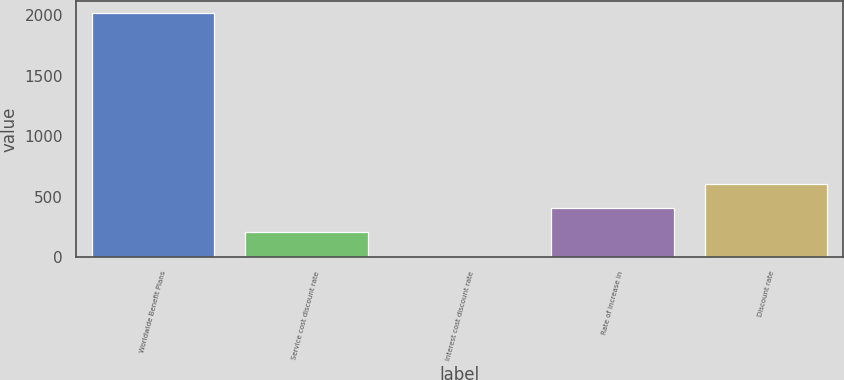<chart> <loc_0><loc_0><loc_500><loc_500><bar_chart><fcel>Worldwide Benefit Plans<fcel>Service cost discount rate<fcel>Interest cost discount rate<fcel>Rate of increase in<fcel>Discount rate<nl><fcel>2018<fcel>205.06<fcel>3.62<fcel>406.5<fcel>607.94<nl></chart> 